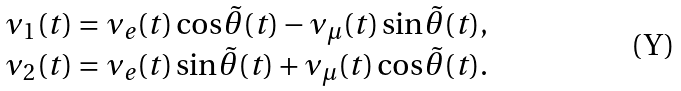<formula> <loc_0><loc_0><loc_500><loc_500>\begin{array} { c } \nu _ { 1 } ( t ) = \nu _ { e } ( t ) \cos \tilde { \theta } ( t ) - \nu _ { \mu } ( t ) \sin \tilde { \theta } ( t ) , \\ \nu _ { 2 } ( t ) = \nu _ { e } ( t ) \sin \tilde { \theta } ( t ) + \nu _ { \mu } ( t ) \cos \tilde { \theta } ( t ) . \end{array}</formula> 